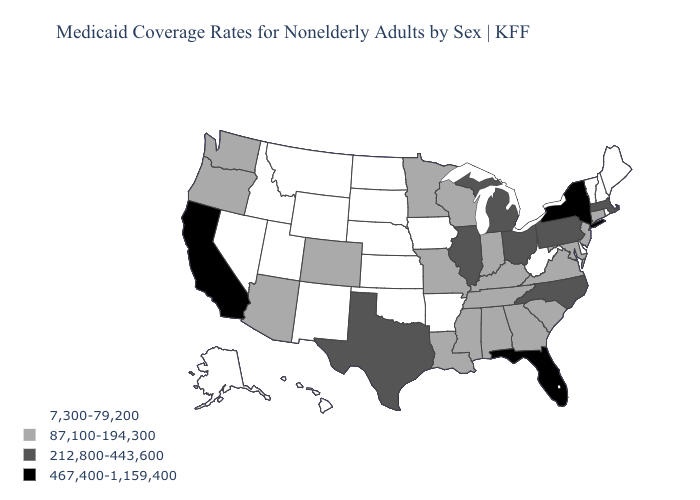Name the states that have a value in the range 467,400-1,159,400?
Be succinct. California, Florida, New York. Name the states that have a value in the range 212,800-443,600?
Quick response, please. Illinois, Massachusetts, Michigan, North Carolina, Ohio, Pennsylvania, Texas. Among the states that border New Jersey , does Delaware have the lowest value?
Be succinct. Yes. What is the lowest value in the West?
Give a very brief answer. 7,300-79,200. Name the states that have a value in the range 87,100-194,300?
Be succinct. Alabama, Arizona, Colorado, Connecticut, Georgia, Indiana, Kentucky, Louisiana, Maryland, Minnesota, Mississippi, Missouri, New Jersey, Oregon, South Carolina, Tennessee, Virginia, Washington, Wisconsin. What is the value of Virginia?
Answer briefly. 87,100-194,300. What is the value of Tennessee?
Short answer required. 87,100-194,300. Does South Carolina have the same value as Michigan?
Short answer required. No. Among the states that border Georgia , does Alabama have the highest value?
Give a very brief answer. No. What is the value of Maine?
Write a very short answer. 7,300-79,200. Does Vermont have the lowest value in the USA?
Answer briefly. Yes. What is the value of Pennsylvania?
Be succinct. 212,800-443,600. How many symbols are there in the legend?
Short answer required. 4. Does Delaware have the same value as North Carolina?
Concise answer only. No. Which states have the highest value in the USA?
Quick response, please. California, Florida, New York. 